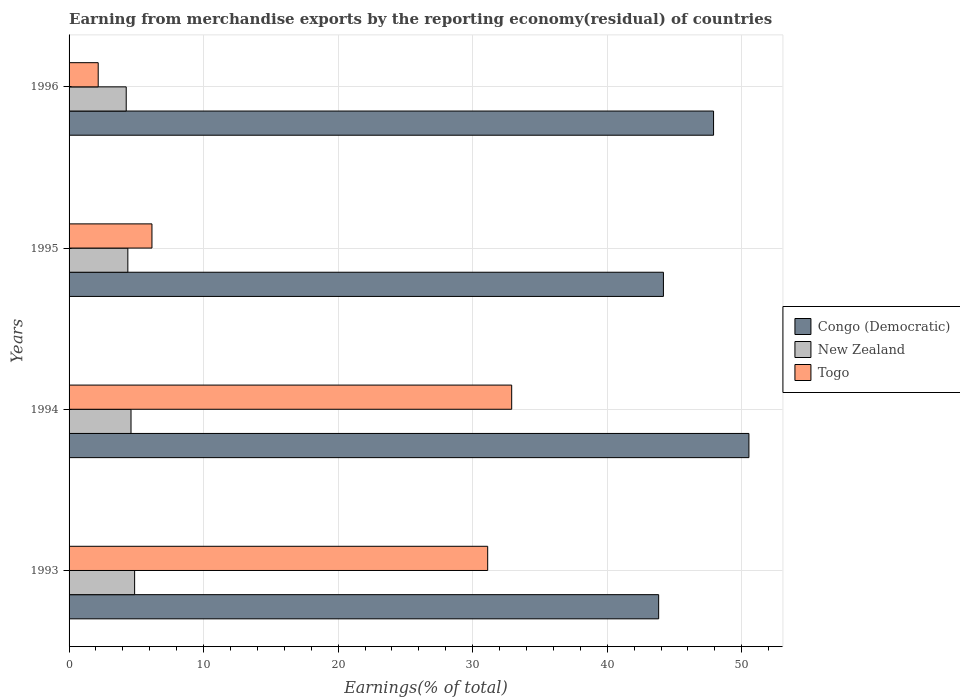Are the number of bars per tick equal to the number of legend labels?
Give a very brief answer. Yes. Are the number of bars on each tick of the Y-axis equal?
Offer a terse response. Yes. How many bars are there on the 2nd tick from the top?
Your response must be concise. 3. How many bars are there on the 3rd tick from the bottom?
Provide a short and direct response. 3. What is the label of the 1st group of bars from the top?
Give a very brief answer. 1996. What is the percentage of amount earned from merchandise exports in New Zealand in 1994?
Give a very brief answer. 4.6. Across all years, what is the maximum percentage of amount earned from merchandise exports in Togo?
Keep it short and to the point. 32.9. Across all years, what is the minimum percentage of amount earned from merchandise exports in New Zealand?
Provide a succinct answer. 4.25. In which year was the percentage of amount earned from merchandise exports in Togo maximum?
Make the answer very short. 1994. What is the total percentage of amount earned from merchandise exports in Togo in the graph?
Offer a terse response. 72.34. What is the difference between the percentage of amount earned from merchandise exports in New Zealand in 1995 and that in 1996?
Make the answer very short. 0.12. What is the difference between the percentage of amount earned from merchandise exports in New Zealand in 1994 and the percentage of amount earned from merchandise exports in Togo in 1995?
Ensure brevity in your answer.  -1.56. What is the average percentage of amount earned from merchandise exports in Togo per year?
Provide a succinct answer. 18.08. In the year 1994, what is the difference between the percentage of amount earned from merchandise exports in Congo (Democratic) and percentage of amount earned from merchandise exports in Togo?
Keep it short and to the point. 17.63. What is the ratio of the percentage of amount earned from merchandise exports in New Zealand in 1994 to that in 1996?
Your answer should be very brief. 1.08. Is the percentage of amount earned from merchandise exports in New Zealand in 1993 less than that in 1994?
Make the answer very short. No. What is the difference between the highest and the second highest percentage of amount earned from merchandise exports in Togo?
Your answer should be compact. 1.78. What is the difference between the highest and the lowest percentage of amount earned from merchandise exports in Togo?
Provide a succinct answer. 30.73. In how many years, is the percentage of amount earned from merchandise exports in Togo greater than the average percentage of amount earned from merchandise exports in Togo taken over all years?
Your response must be concise. 2. What does the 2nd bar from the top in 1994 represents?
Offer a very short reply. New Zealand. What does the 1st bar from the bottom in 1993 represents?
Provide a short and direct response. Congo (Democratic). Are all the bars in the graph horizontal?
Ensure brevity in your answer.  Yes. How many years are there in the graph?
Give a very brief answer. 4. Does the graph contain grids?
Provide a succinct answer. Yes. How many legend labels are there?
Offer a terse response. 3. What is the title of the graph?
Give a very brief answer. Earning from merchandise exports by the reporting economy(residual) of countries. Does "St. Kitts and Nevis" appear as one of the legend labels in the graph?
Your response must be concise. No. What is the label or title of the X-axis?
Your answer should be very brief. Earnings(% of total). What is the label or title of the Y-axis?
Give a very brief answer. Years. What is the Earnings(% of total) of Congo (Democratic) in 1993?
Offer a terse response. 43.82. What is the Earnings(% of total) of New Zealand in 1993?
Provide a succinct answer. 4.87. What is the Earnings(% of total) in Togo in 1993?
Keep it short and to the point. 31.11. What is the Earnings(% of total) in Congo (Democratic) in 1994?
Make the answer very short. 50.53. What is the Earnings(% of total) in New Zealand in 1994?
Your answer should be very brief. 4.6. What is the Earnings(% of total) of Togo in 1994?
Make the answer very short. 32.9. What is the Earnings(% of total) in Congo (Democratic) in 1995?
Keep it short and to the point. 44.17. What is the Earnings(% of total) in New Zealand in 1995?
Make the answer very short. 4.37. What is the Earnings(% of total) of Togo in 1995?
Offer a very short reply. 6.16. What is the Earnings(% of total) of Congo (Democratic) in 1996?
Your response must be concise. 47.9. What is the Earnings(% of total) of New Zealand in 1996?
Make the answer very short. 4.25. What is the Earnings(% of total) of Togo in 1996?
Make the answer very short. 2.17. Across all years, what is the maximum Earnings(% of total) in Congo (Democratic)?
Provide a short and direct response. 50.53. Across all years, what is the maximum Earnings(% of total) of New Zealand?
Ensure brevity in your answer.  4.87. Across all years, what is the maximum Earnings(% of total) in Togo?
Your answer should be compact. 32.9. Across all years, what is the minimum Earnings(% of total) in Congo (Democratic)?
Give a very brief answer. 43.82. Across all years, what is the minimum Earnings(% of total) of New Zealand?
Your answer should be very brief. 4.25. Across all years, what is the minimum Earnings(% of total) in Togo?
Provide a short and direct response. 2.17. What is the total Earnings(% of total) in Congo (Democratic) in the graph?
Provide a short and direct response. 186.42. What is the total Earnings(% of total) in New Zealand in the graph?
Make the answer very short. 18.09. What is the total Earnings(% of total) in Togo in the graph?
Offer a very short reply. 72.34. What is the difference between the Earnings(% of total) in Congo (Democratic) in 1993 and that in 1994?
Keep it short and to the point. -6.71. What is the difference between the Earnings(% of total) in New Zealand in 1993 and that in 1994?
Ensure brevity in your answer.  0.27. What is the difference between the Earnings(% of total) in Togo in 1993 and that in 1994?
Keep it short and to the point. -1.78. What is the difference between the Earnings(% of total) of Congo (Democratic) in 1993 and that in 1995?
Give a very brief answer. -0.35. What is the difference between the Earnings(% of total) in New Zealand in 1993 and that in 1995?
Your response must be concise. 0.5. What is the difference between the Earnings(% of total) of Togo in 1993 and that in 1995?
Provide a succinct answer. 24.95. What is the difference between the Earnings(% of total) in Congo (Democratic) in 1993 and that in 1996?
Keep it short and to the point. -4.08. What is the difference between the Earnings(% of total) of New Zealand in 1993 and that in 1996?
Your answer should be compact. 0.62. What is the difference between the Earnings(% of total) in Togo in 1993 and that in 1996?
Give a very brief answer. 28.95. What is the difference between the Earnings(% of total) in Congo (Democratic) in 1994 and that in 1995?
Provide a succinct answer. 6.35. What is the difference between the Earnings(% of total) of New Zealand in 1994 and that in 1995?
Offer a very short reply. 0.24. What is the difference between the Earnings(% of total) of Togo in 1994 and that in 1995?
Ensure brevity in your answer.  26.74. What is the difference between the Earnings(% of total) in Congo (Democratic) in 1994 and that in 1996?
Provide a succinct answer. 2.63. What is the difference between the Earnings(% of total) of New Zealand in 1994 and that in 1996?
Provide a short and direct response. 0.36. What is the difference between the Earnings(% of total) in Togo in 1994 and that in 1996?
Make the answer very short. 30.73. What is the difference between the Earnings(% of total) in Congo (Democratic) in 1995 and that in 1996?
Offer a very short reply. -3.73. What is the difference between the Earnings(% of total) in New Zealand in 1995 and that in 1996?
Your answer should be very brief. 0.12. What is the difference between the Earnings(% of total) of Togo in 1995 and that in 1996?
Ensure brevity in your answer.  3.99. What is the difference between the Earnings(% of total) of Congo (Democratic) in 1993 and the Earnings(% of total) of New Zealand in 1994?
Provide a succinct answer. 39.22. What is the difference between the Earnings(% of total) in Congo (Democratic) in 1993 and the Earnings(% of total) in Togo in 1994?
Offer a very short reply. 10.92. What is the difference between the Earnings(% of total) in New Zealand in 1993 and the Earnings(% of total) in Togo in 1994?
Your response must be concise. -28.02. What is the difference between the Earnings(% of total) of Congo (Democratic) in 1993 and the Earnings(% of total) of New Zealand in 1995?
Your answer should be compact. 39.45. What is the difference between the Earnings(% of total) of Congo (Democratic) in 1993 and the Earnings(% of total) of Togo in 1995?
Offer a very short reply. 37.66. What is the difference between the Earnings(% of total) in New Zealand in 1993 and the Earnings(% of total) in Togo in 1995?
Give a very brief answer. -1.29. What is the difference between the Earnings(% of total) in Congo (Democratic) in 1993 and the Earnings(% of total) in New Zealand in 1996?
Ensure brevity in your answer.  39.57. What is the difference between the Earnings(% of total) of Congo (Democratic) in 1993 and the Earnings(% of total) of Togo in 1996?
Offer a very short reply. 41.65. What is the difference between the Earnings(% of total) of New Zealand in 1993 and the Earnings(% of total) of Togo in 1996?
Provide a short and direct response. 2.71. What is the difference between the Earnings(% of total) in Congo (Democratic) in 1994 and the Earnings(% of total) in New Zealand in 1995?
Make the answer very short. 46.16. What is the difference between the Earnings(% of total) in Congo (Democratic) in 1994 and the Earnings(% of total) in Togo in 1995?
Provide a short and direct response. 44.37. What is the difference between the Earnings(% of total) in New Zealand in 1994 and the Earnings(% of total) in Togo in 1995?
Provide a succinct answer. -1.56. What is the difference between the Earnings(% of total) of Congo (Democratic) in 1994 and the Earnings(% of total) of New Zealand in 1996?
Your answer should be compact. 46.28. What is the difference between the Earnings(% of total) in Congo (Democratic) in 1994 and the Earnings(% of total) in Togo in 1996?
Offer a terse response. 48.36. What is the difference between the Earnings(% of total) of New Zealand in 1994 and the Earnings(% of total) of Togo in 1996?
Give a very brief answer. 2.44. What is the difference between the Earnings(% of total) of Congo (Democratic) in 1995 and the Earnings(% of total) of New Zealand in 1996?
Your answer should be compact. 39.93. What is the difference between the Earnings(% of total) in Congo (Democratic) in 1995 and the Earnings(% of total) in Togo in 1996?
Your answer should be compact. 42.01. What is the difference between the Earnings(% of total) of New Zealand in 1995 and the Earnings(% of total) of Togo in 1996?
Your answer should be compact. 2.2. What is the average Earnings(% of total) of Congo (Democratic) per year?
Your response must be concise. 46.61. What is the average Earnings(% of total) of New Zealand per year?
Give a very brief answer. 4.52. What is the average Earnings(% of total) in Togo per year?
Offer a terse response. 18.08. In the year 1993, what is the difference between the Earnings(% of total) in Congo (Democratic) and Earnings(% of total) in New Zealand?
Your response must be concise. 38.95. In the year 1993, what is the difference between the Earnings(% of total) of Congo (Democratic) and Earnings(% of total) of Togo?
Your answer should be compact. 12.71. In the year 1993, what is the difference between the Earnings(% of total) of New Zealand and Earnings(% of total) of Togo?
Make the answer very short. -26.24. In the year 1994, what is the difference between the Earnings(% of total) of Congo (Democratic) and Earnings(% of total) of New Zealand?
Offer a terse response. 45.92. In the year 1994, what is the difference between the Earnings(% of total) in Congo (Democratic) and Earnings(% of total) in Togo?
Give a very brief answer. 17.63. In the year 1994, what is the difference between the Earnings(% of total) in New Zealand and Earnings(% of total) in Togo?
Provide a succinct answer. -28.29. In the year 1995, what is the difference between the Earnings(% of total) in Congo (Democratic) and Earnings(% of total) in New Zealand?
Make the answer very short. 39.81. In the year 1995, what is the difference between the Earnings(% of total) of Congo (Democratic) and Earnings(% of total) of Togo?
Your response must be concise. 38.01. In the year 1995, what is the difference between the Earnings(% of total) in New Zealand and Earnings(% of total) in Togo?
Provide a short and direct response. -1.79. In the year 1996, what is the difference between the Earnings(% of total) in Congo (Democratic) and Earnings(% of total) in New Zealand?
Offer a very short reply. 43.65. In the year 1996, what is the difference between the Earnings(% of total) of Congo (Democratic) and Earnings(% of total) of Togo?
Offer a very short reply. 45.74. In the year 1996, what is the difference between the Earnings(% of total) of New Zealand and Earnings(% of total) of Togo?
Ensure brevity in your answer.  2.08. What is the ratio of the Earnings(% of total) of Congo (Democratic) in 1993 to that in 1994?
Your answer should be very brief. 0.87. What is the ratio of the Earnings(% of total) in New Zealand in 1993 to that in 1994?
Make the answer very short. 1.06. What is the ratio of the Earnings(% of total) in Togo in 1993 to that in 1994?
Your answer should be very brief. 0.95. What is the ratio of the Earnings(% of total) in Congo (Democratic) in 1993 to that in 1995?
Your answer should be compact. 0.99. What is the ratio of the Earnings(% of total) in New Zealand in 1993 to that in 1995?
Make the answer very short. 1.12. What is the ratio of the Earnings(% of total) of Togo in 1993 to that in 1995?
Make the answer very short. 5.05. What is the ratio of the Earnings(% of total) in Congo (Democratic) in 1993 to that in 1996?
Your answer should be very brief. 0.91. What is the ratio of the Earnings(% of total) in New Zealand in 1993 to that in 1996?
Your answer should be compact. 1.15. What is the ratio of the Earnings(% of total) of Togo in 1993 to that in 1996?
Your answer should be compact. 14.37. What is the ratio of the Earnings(% of total) of Congo (Democratic) in 1994 to that in 1995?
Ensure brevity in your answer.  1.14. What is the ratio of the Earnings(% of total) of New Zealand in 1994 to that in 1995?
Your answer should be very brief. 1.05. What is the ratio of the Earnings(% of total) in Togo in 1994 to that in 1995?
Your answer should be compact. 5.34. What is the ratio of the Earnings(% of total) in Congo (Democratic) in 1994 to that in 1996?
Give a very brief answer. 1.05. What is the ratio of the Earnings(% of total) of New Zealand in 1994 to that in 1996?
Provide a short and direct response. 1.08. What is the ratio of the Earnings(% of total) of Togo in 1994 to that in 1996?
Ensure brevity in your answer.  15.19. What is the ratio of the Earnings(% of total) in Congo (Democratic) in 1995 to that in 1996?
Offer a very short reply. 0.92. What is the ratio of the Earnings(% of total) of New Zealand in 1995 to that in 1996?
Give a very brief answer. 1.03. What is the ratio of the Earnings(% of total) of Togo in 1995 to that in 1996?
Offer a very short reply. 2.84. What is the difference between the highest and the second highest Earnings(% of total) of Congo (Democratic)?
Offer a very short reply. 2.63. What is the difference between the highest and the second highest Earnings(% of total) of New Zealand?
Your answer should be very brief. 0.27. What is the difference between the highest and the second highest Earnings(% of total) in Togo?
Give a very brief answer. 1.78. What is the difference between the highest and the lowest Earnings(% of total) of Congo (Democratic)?
Provide a succinct answer. 6.71. What is the difference between the highest and the lowest Earnings(% of total) in New Zealand?
Make the answer very short. 0.62. What is the difference between the highest and the lowest Earnings(% of total) in Togo?
Offer a terse response. 30.73. 